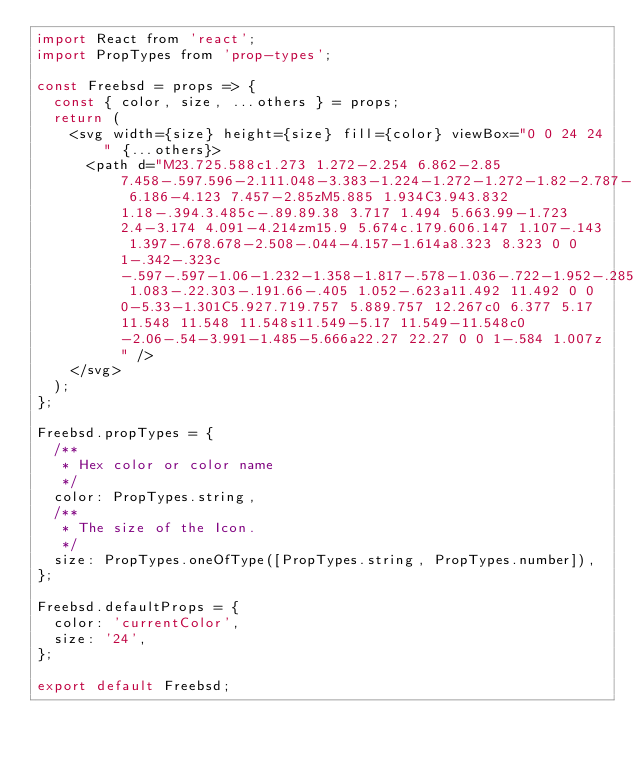<code> <loc_0><loc_0><loc_500><loc_500><_JavaScript_>import React from 'react';
import PropTypes from 'prop-types';

const Freebsd = props => {
  const { color, size, ...others } = props;
  return (
    <svg width={size} height={size} fill={color} viewBox="0 0 24 24" {...others}>
      <path d="M23.725.588c1.273 1.272-2.254 6.862-2.85 7.458-.597.596-2.111.048-3.383-1.224-1.272-1.272-1.82-2.787-1.224-3.383.596-.596 6.186-4.123 7.457-2.85zM5.885 1.934C3.943.832 1.18-.394.3.485c-.89.89.38 3.717 1.494 5.663.99-1.723 2.4-3.174 4.091-4.214zm15.9 5.674c.179.606.147 1.107-.143 1.397-.678.678-2.508-.044-4.157-1.614a8.323 8.323 0 0 1-.342-.323c-.597-.597-1.06-1.232-1.358-1.817-.578-1.036-.722-1.952-.285-2.388.238-.238.618-.303 1.083-.22.303-.191.66-.405 1.052-.623a11.492 11.492 0 0 0-5.33-1.301C5.927.719.757 5.889.757 12.267c0 6.377 5.17 11.548 11.548 11.548s11.549-5.17 11.549-11.548c0-2.06-.54-3.991-1.485-5.666a22.27 22.27 0 0 1-.584 1.007z" />
    </svg>
  );
};

Freebsd.propTypes = {
  /**
   * Hex color or color name
   */
  color: PropTypes.string,
  /**
   * The size of the Icon.
   */
  size: PropTypes.oneOfType([PropTypes.string, PropTypes.number]),
};

Freebsd.defaultProps = {
  color: 'currentColor',
  size: '24',
};

export default Freebsd;
</code> 